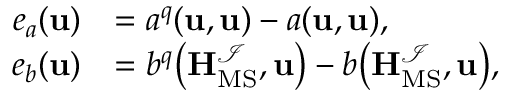<formula> <loc_0><loc_0><loc_500><loc_500>\begin{array} { r l } { e _ { a } ( u ) } & { = a ^ { q } ( u , u ) - a ( u , u ) , } \\ { e _ { b } ( u ) } & { = b ^ { q } \left ( H _ { M S } ^ { \mathcal { I } } , u \right ) - b \left ( H _ { M S } ^ { \mathcal { I } } , u \right ) , } \end{array}</formula> 